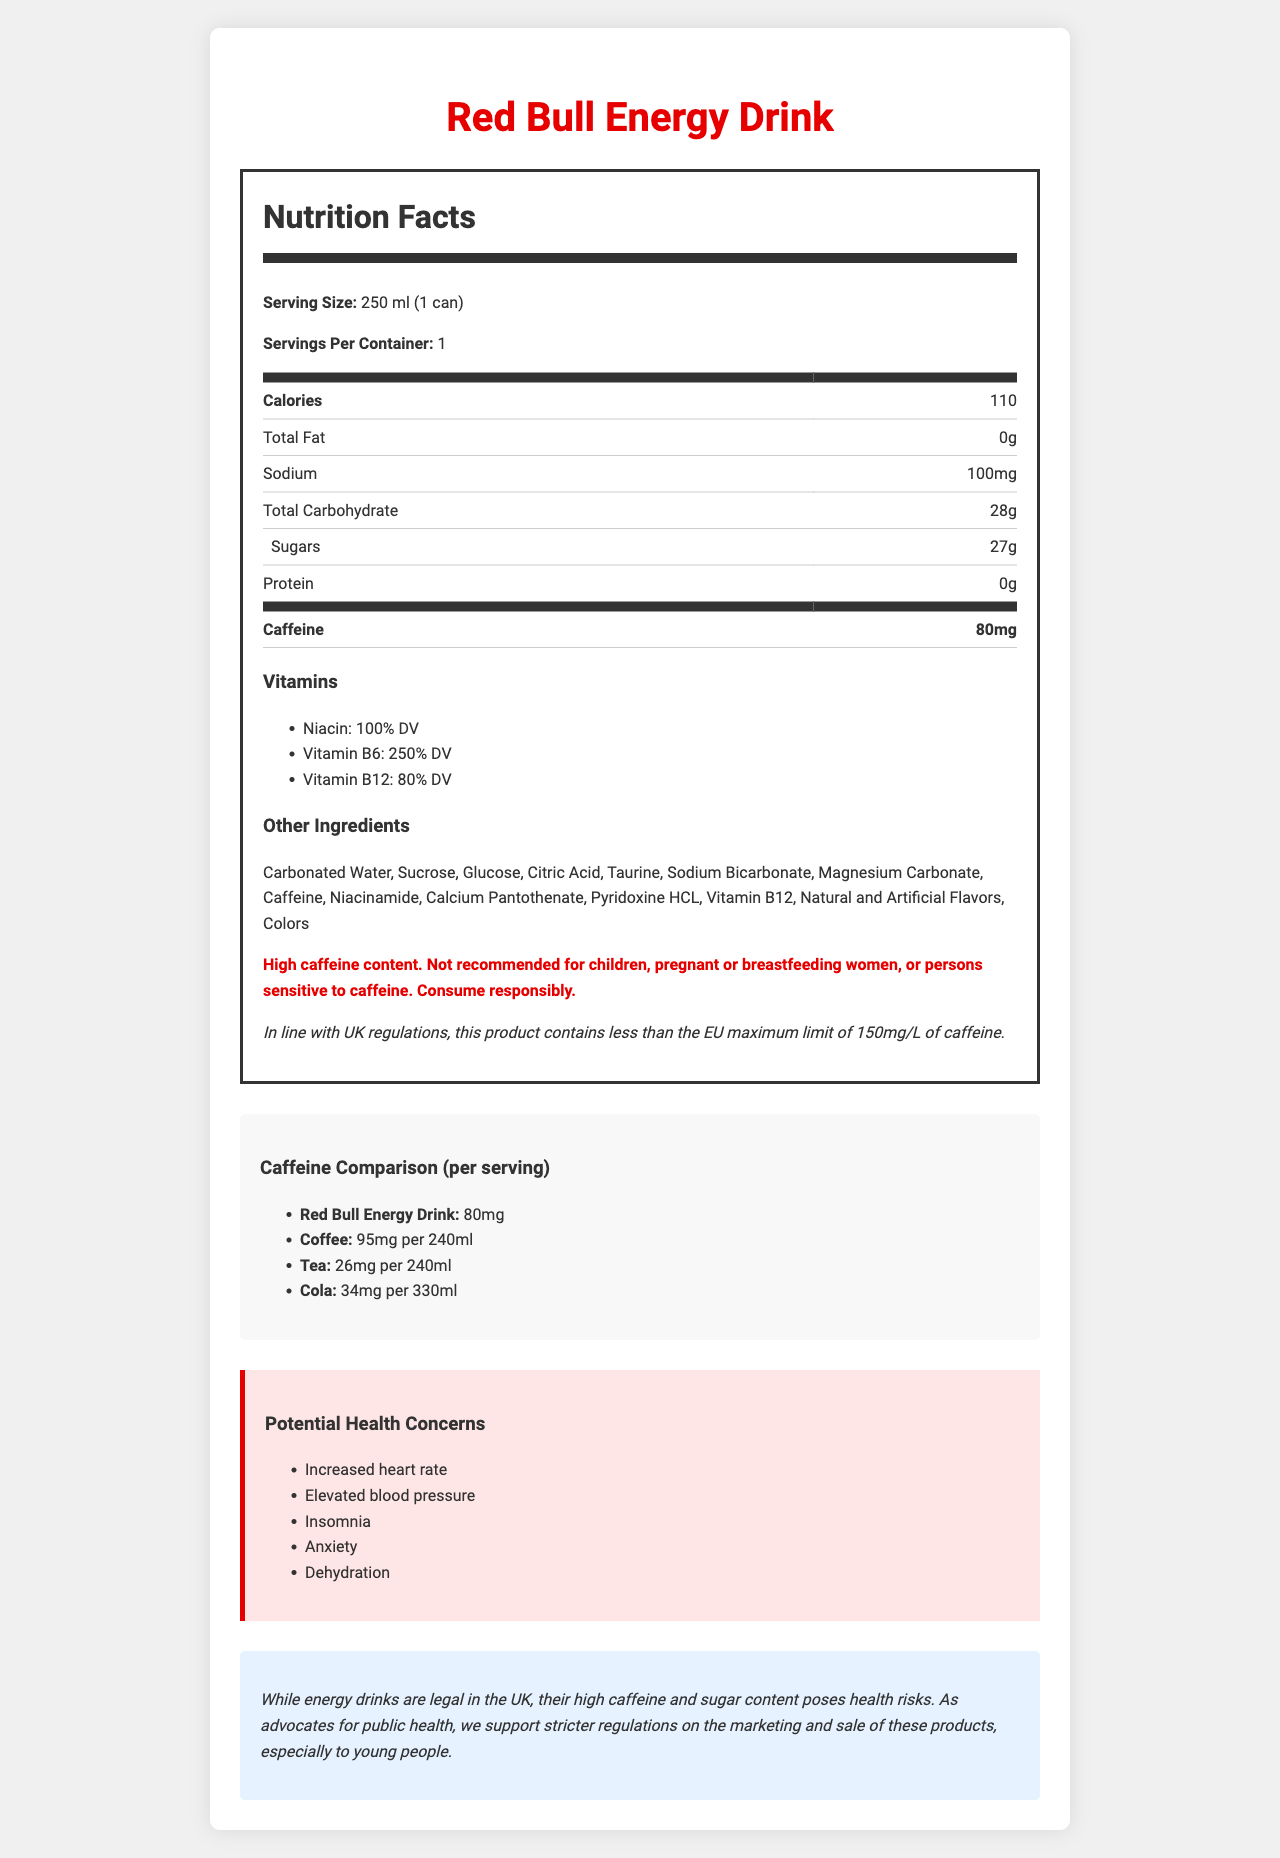what is the recommended serving size? The serving size is stated as "250 ml (1 can)" in the nutrition facts section of the document.
Answer: 250 ml (1 can) how many calories are in one serving? Under the nutrition facts, it specifies that there are 110 calories per serving.
Answer: 110 calories what is the total carbohydrate content in one serving? The nutrition facts table lists the total carbohydrate content as "28g".
Answer: 28g what is the sodium content per serving? The sodium content per serving is mentioned as "100mg" in the nutrition facts table.
Answer: 100mg what is the caffeine content in one can of this energy drink? The nutrition label highlights the caffeine content as "80mg".
Answer: 80mg how does the caffeine content of this energy drink compare to coffee? A. Higher B. Lower C. About the same D. Not mentioned The caffeine comparison section states that coffee has "95mg per 240ml", which is higher than the energy drink's "80mg".
Answer: B which vitamins are contained in this energy drink? A. Vitamin A, Vitamin D B. Niacin, Vitamin B6, Vitamin B12 C. Vitamin C, Vitamin E The document lists the vitamins as "Niacin", "Vitamin B6", and "Vitamin B12".
Answer: B is this product recommended for children? The warning statement clearly indicates that the product is "Not recommended for children".
Answer: No what health concerns are associated with high caffeine intake mentioned in the document? The health concerns section lists these effects.
Answer: Increased heart rate, Elevated blood pressure, Insomnia, Anxiety, Dehydration what does the uk regulation note mention about the caffeine content? The regulation note specifies that the caffeine content is within the EU maximum limit.
Answer: This product contains less than the EU maximum limit of 150mg/L of caffeine. why should stricter regulations be considered for energy drinks like this in the UK? The advocacy message supports stricter regulations due to health risks associated with high caffeine and sugar content.
Answer: Their high caffeine and sugar content poses health risks, especially to young people. how much sugar is in one can of this energy drink? The sugars content is listed as "27g" in the nutrition facts section.
Answer: 27g how does the caffeine content of this energy drink compare to tea? The caffeine comparison shows tea has "26mg per 240ml" while the energy drink has "80mg".
Answer: Higher can you list all the other ingredients in this energy drink? The document provides a detailed list of these ingredients.
Answer: Carbonated Water, Sucrose, Glucose, Citric Acid, Taurine, Sodium Bicarbonate, Magnesium Carbonate, Caffeine, Niacinamide, Calcium Pantothenate, Pyridoxine HCL, Vitamin B12, Natural and Artificial Flavors, Colors how many percent daily value (DV) of Vitamin B6 does this energy drink provide? The vitamins section states that Vitamin B6 provides "250% DV".
Answer: 250% DV are pregnant women advised to consume this energy drink? A. Yes B. No C. Sometimes D. Not mentioned The warning statement mentions it is "Not recommended for... pregnant or breastfeeding women".
Answer: B what is the main idea of this document? Detailed nutritional facts are presented along with warnings and advocacy for stricter regulations due to health risks.
Answer: The document provides nutritional information for Red Bull Energy Drink, emphasizing its high caffeine content, potential health risks, and advocating for stricter regulations. why does consuming this energy drink pose potential health risks? The health concerns section highlights the risks associated with its high caffeine and sugar content.
Answer: High caffeine and sugar content can lead to increased heart rate, elevated blood pressure, insomnia, anxiety, and dehydration. what is the price of this energy drink? The document does not mention the price of the energy drink.
Answer: Cannot be determined 